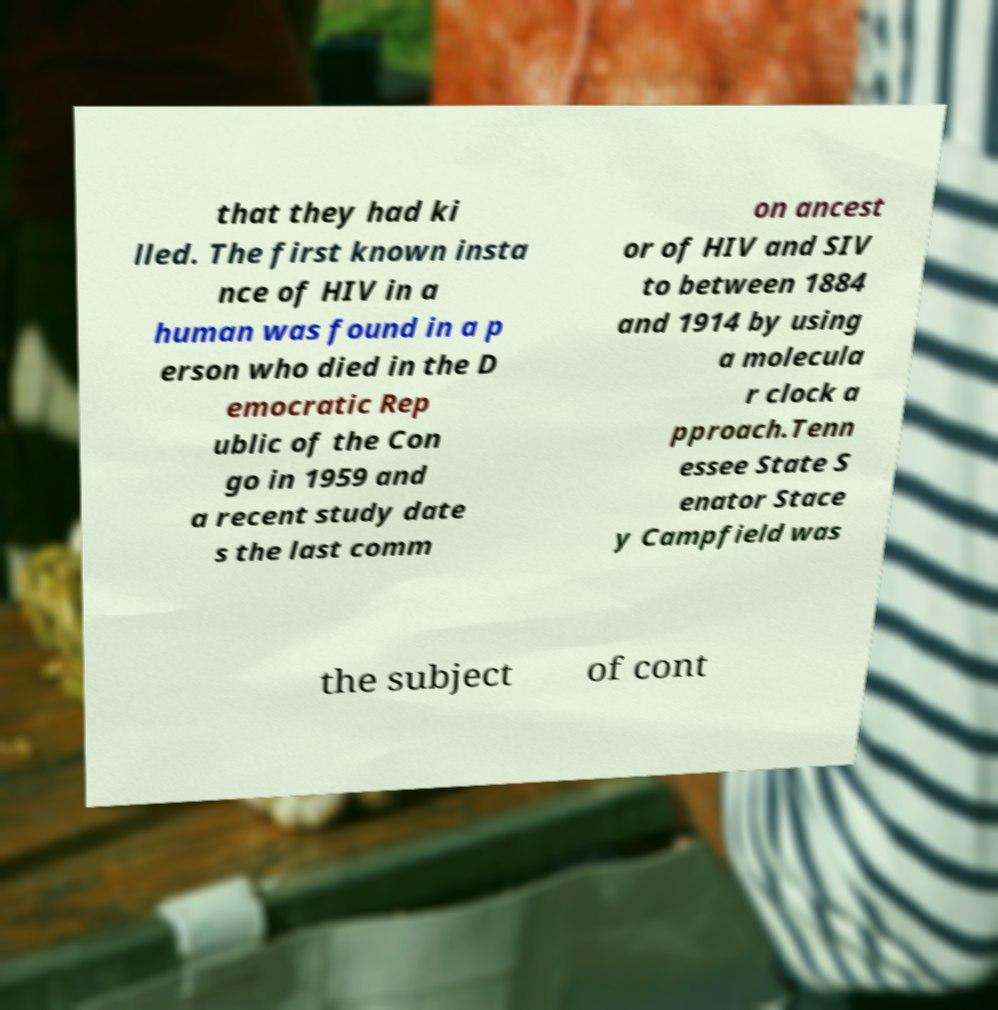Please read and relay the text visible in this image. What does it say? that they had ki lled. The first known insta nce of HIV in a human was found in a p erson who died in the D emocratic Rep ublic of the Con go in 1959 and a recent study date s the last comm on ancest or of HIV and SIV to between 1884 and 1914 by using a molecula r clock a pproach.Tenn essee State S enator Stace y Campfield was the subject of cont 